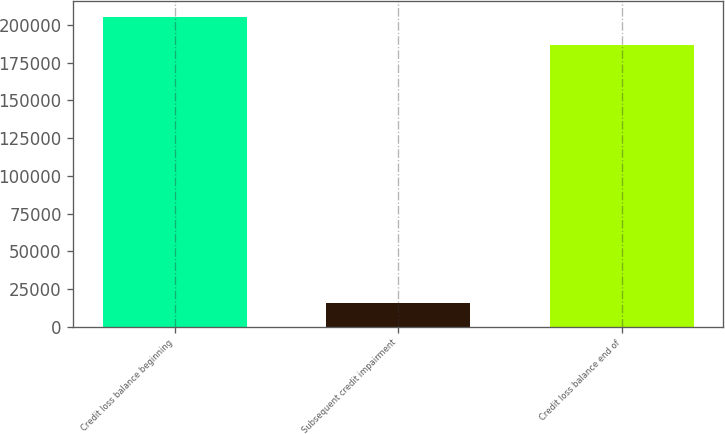<chart> <loc_0><loc_0><loc_500><loc_500><bar_chart><fcel>Credit loss balance beginning<fcel>Subsequent credit impairment<fcel>Credit loss balance end of<nl><fcel>205423<fcel>15938<fcel>186722<nl></chart> 